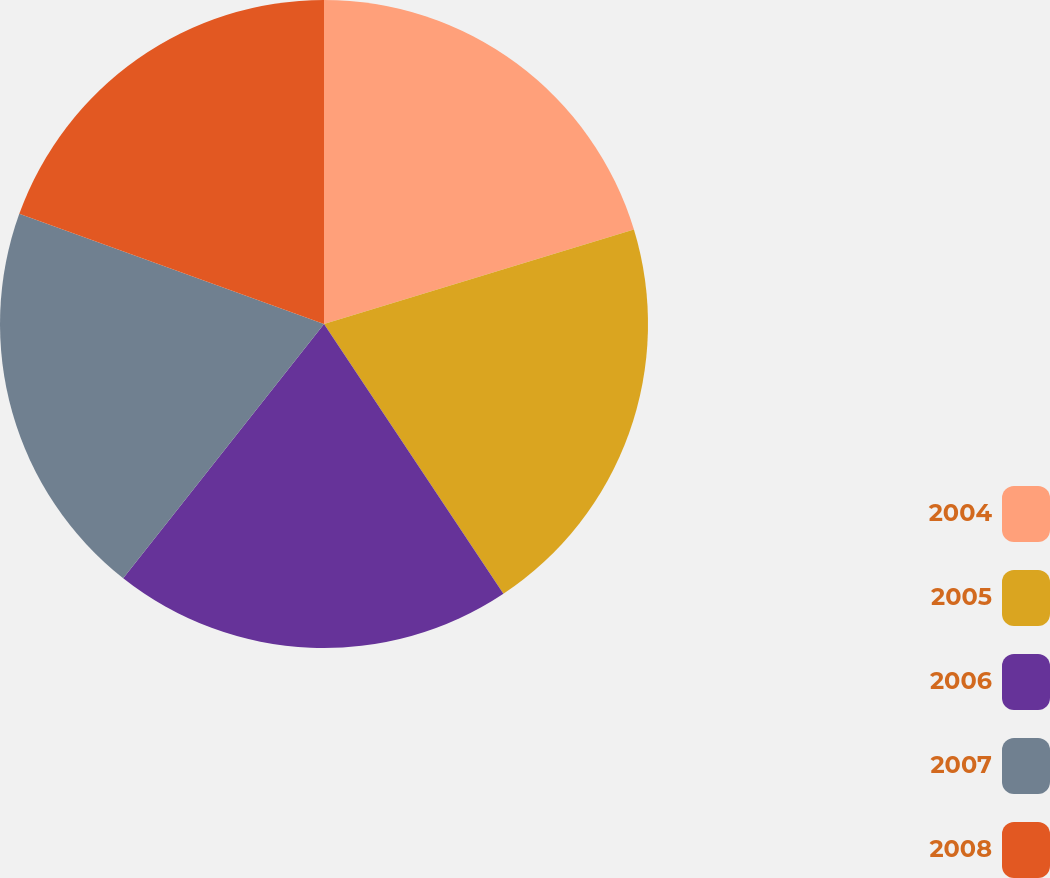Convert chart. <chart><loc_0><loc_0><loc_500><loc_500><pie_chart><fcel>2004<fcel>2005<fcel>2006<fcel>2007<fcel>2008<nl><fcel>20.29%<fcel>20.37%<fcel>19.98%<fcel>19.88%<fcel>19.48%<nl></chart> 